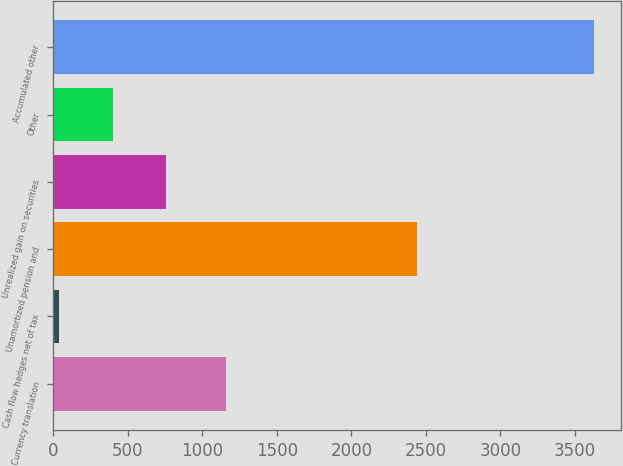Convert chart to OTSL. <chart><loc_0><loc_0><loc_500><loc_500><bar_chart><fcel>Currency translation<fcel>Cash flow hedges net of tax<fcel>Unamortized pension and<fcel>Unrealized gain on securities<fcel>Other<fcel>Accumulated other<nl><fcel>1159<fcel>38<fcel>2442<fcel>756.4<fcel>397.2<fcel>3630<nl></chart> 